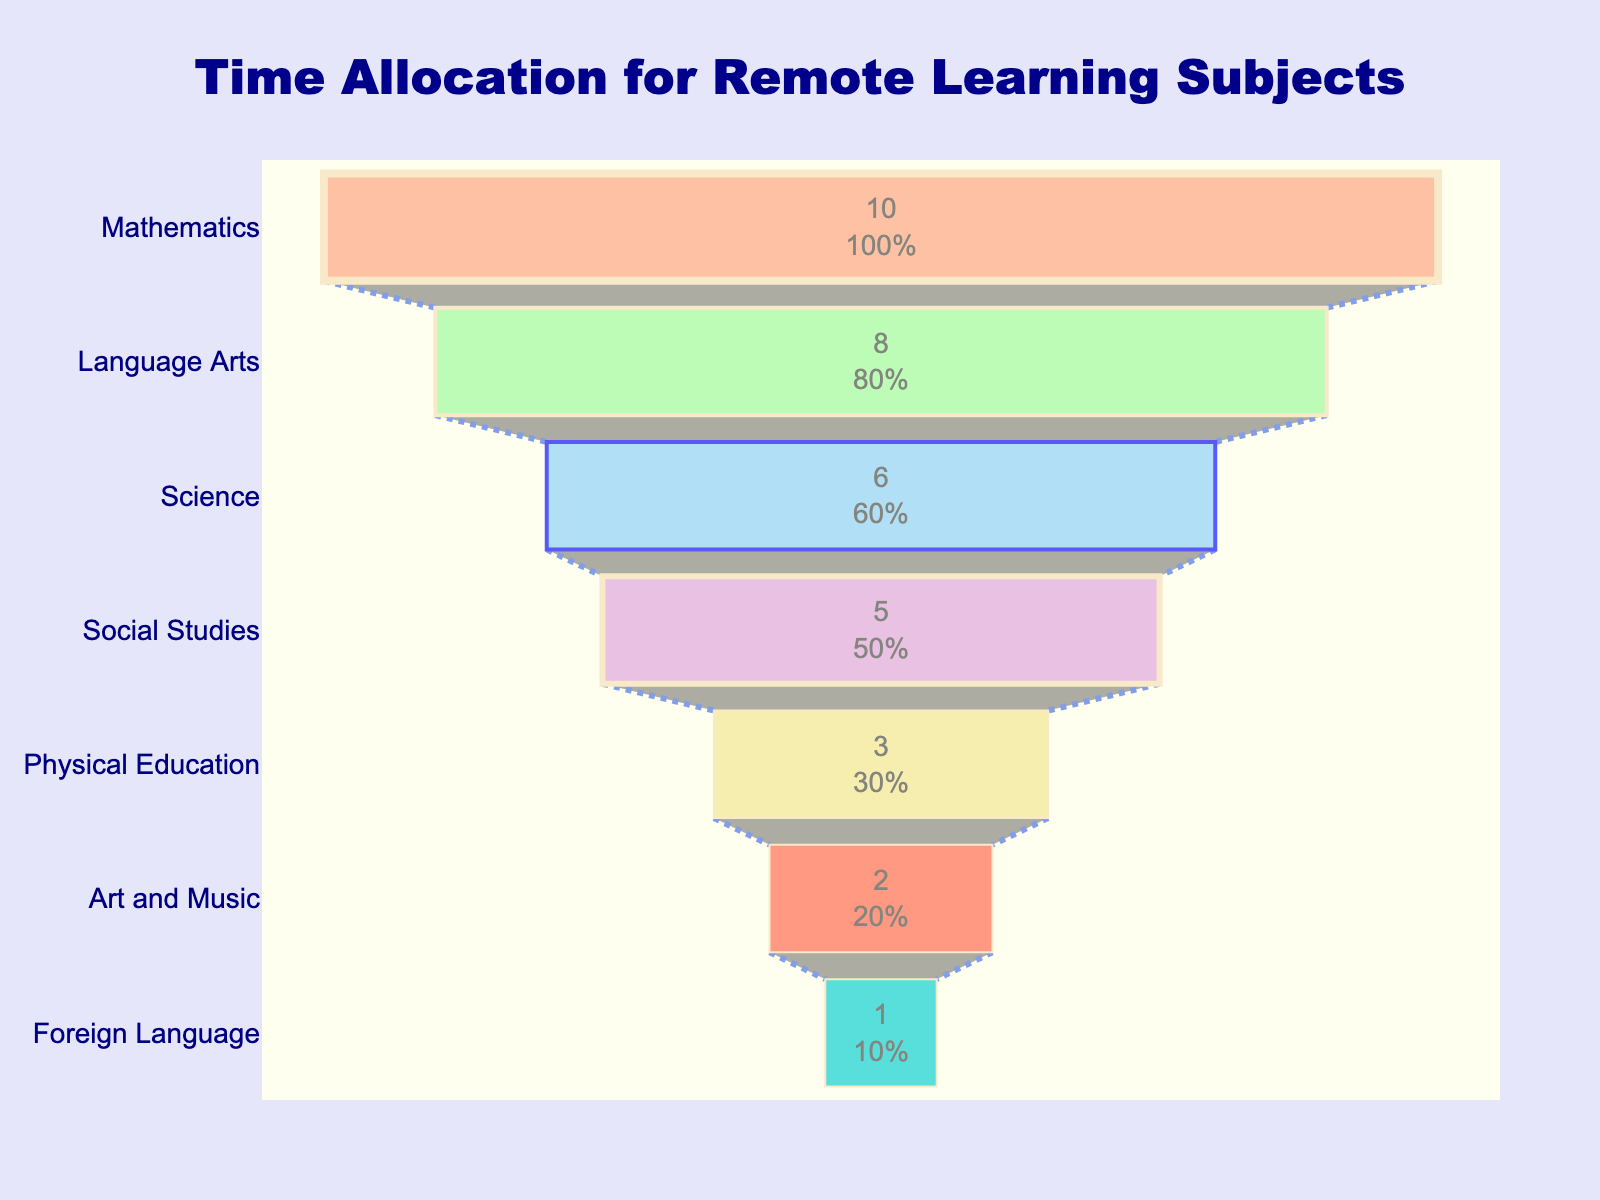What is the title of the funnel chart? The title is displayed at the top center of the chart and reads "Time Allocation for Remote Learning Subjects."
Answer: Time Allocation for Remote Learning Subjects Which subject has the least amount of time spent per week and how many hours is that? The subject with the least amount of time is found at the narrowest part of the funnel, indicating Foreign Language, with 1 hour per week.
Answer: Foreign Language, 1 hour What percentage of total weekly time is spent on Mathematics? Look at the Mathematics value displayed within the funnel chart; it shows both the number of hours and the percentage. The percentage value for Mathematics is given as part of the text info.
Answer: 29% How many hours per week are spent on Science and Social Studies combined? To find the combined hours, add the hours allocated for Science and Social Studies (which are 6 and 5 respectively). The sum is 6 + 5 = 11.
Answer: 11 hours What subject is allocated the second most time, and how many hours are dedicated to it? The second largest section from the top represents the second most time-consuming subject. Language Arts is the subject, with 8 hours per week.
Answer: Language Arts, 8 hours How does the time spent on Physical Education compare to Art and Music? By comparing the corresponding sections of the funnel, one can see that Physical Education is larger than Art and Music. Specifically, 3 hours are spent on Physical Education and 2 hours on Art and Music.
Answer: Physical Education has 1 hour more than Art and Music What is the average time spent per subject per week? To calculate the average, sum the total hours for all subjects and divide by the number of subjects. (10 + 8 + 6 + 5 + 3 + 2 + 1) hours = 35 hours. There are 7 subjects, so the average is 35 / 7 = 5 hours.
Answer: 5 hours Which subject represents roughly 17% of the total time of remote learning? Examine the percentage values displayed inside the funnel sections. Science is shown to represent around 17% of the total time.
Answer: Science If 5 additional hours are allocated to Physical Education each week, how would its rank change in the chart? Currently, Physical Education has 3 hours. Adding 5 hours makes it 3 + 5 = 8 hours. This new total equals Language Arts' time, placing it at the second position from the top.
Answer: It would rank second, equal to Language Arts 